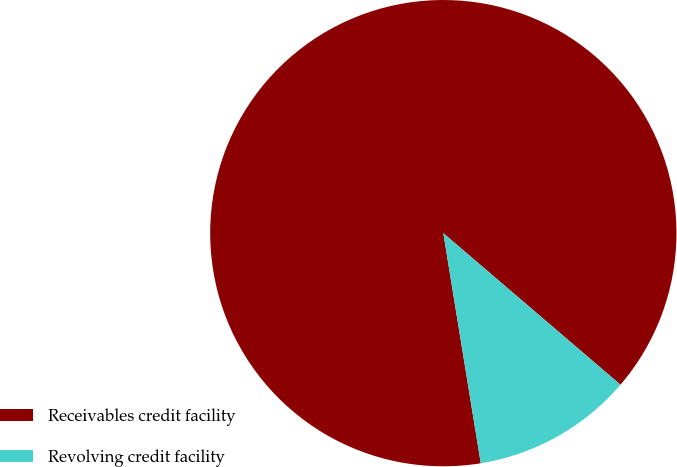Convert chart to OTSL. <chart><loc_0><loc_0><loc_500><loc_500><pie_chart><fcel>Receivables credit facility<fcel>Revolving credit facility<nl><fcel>88.83%<fcel>11.17%<nl></chart> 